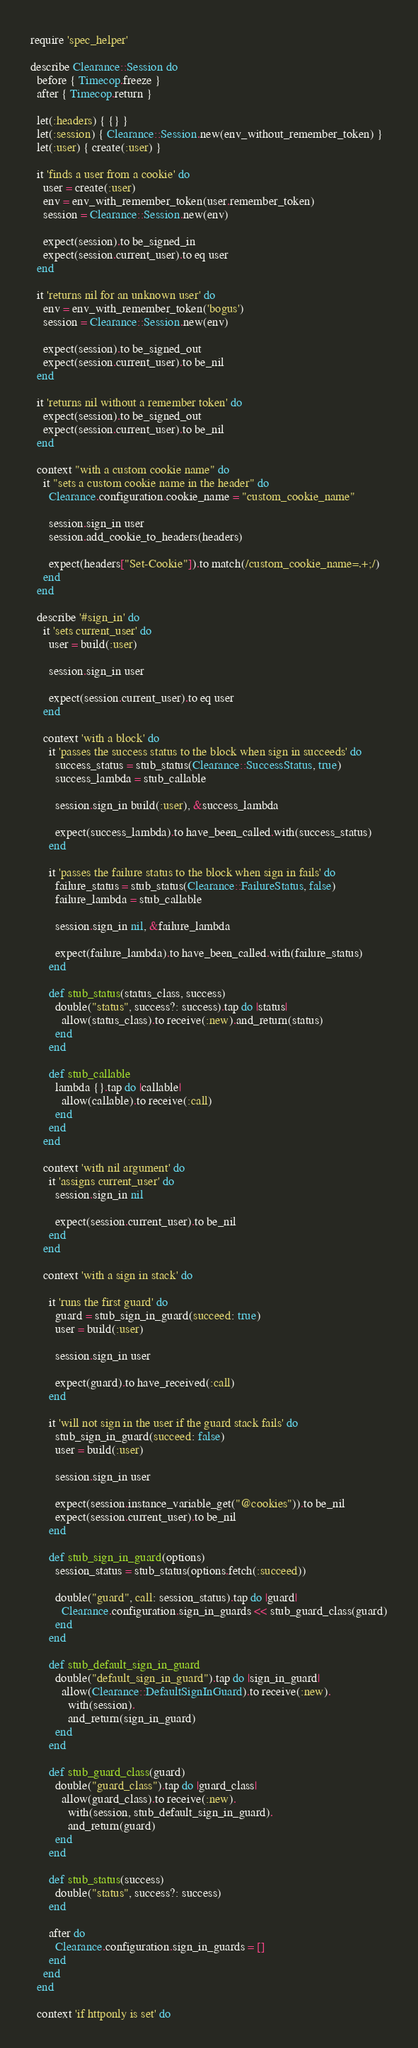Convert code to text. <code><loc_0><loc_0><loc_500><loc_500><_Ruby_>require 'spec_helper'

describe Clearance::Session do
  before { Timecop.freeze }
  after { Timecop.return }

  let(:headers) { {} }
  let(:session) { Clearance::Session.new(env_without_remember_token) }
  let(:user) { create(:user) }

  it 'finds a user from a cookie' do
    user = create(:user)
    env = env_with_remember_token(user.remember_token)
    session = Clearance::Session.new(env)

    expect(session).to be_signed_in
    expect(session.current_user).to eq user
  end

  it 'returns nil for an unknown user' do
    env = env_with_remember_token('bogus')
    session = Clearance::Session.new(env)

    expect(session).to be_signed_out
    expect(session.current_user).to be_nil
  end

  it 'returns nil without a remember token' do
    expect(session).to be_signed_out
    expect(session.current_user).to be_nil
  end

  context "with a custom cookie name" do
    it "sets a custom cookie name in the header" do
      Clearance.configuration.cookie_name = "custom_cookie_name"

      session.sign_in user
      session.add_cookie_to_headers(headers)

      expect(headers["Set-Cookie"]).to match(/custom_cookie_name=.+;/)
    end
  end

  describe '#sign_in' do
    it 'sets current_user' do
      user = build(:user)

      session.sign_in user

      expect(session.current_user).to eq user
    end

    context 'with a block' do
      it 'passes the success status to the block when sign in succeeds' do
        success_status = stub_status(Clearance::SuccessStatus, true)
        success_lambda = stub_callable

        session.sign_in build(:user), &success_lambda

        expect(success_lambda).to have_been_called.with(success_status)
      end

      it 'passes the failure status to the block when sign in fails' do
        failure_status = stub_status(Clearance::FailureStatus, false)
        failure_lambda = stub_callable

        session.sign_in nil, &failure_lambda

        expect(failure_lambda).to have_been_called.with(failure_status)
      end

      def stub_status(status_class, success)
        double("status", success?: success).tap do |status|
          allow(status_class).to receive(:new).and_return(status)
        end
      end

      def stub_callable
        lambda {}.tap do |callable|
          allow(callable).to receive(:call)
        end
      end
    end

    context 'with nil argument' do
      it 'assigns current_user' do
        session.sign_in nil

        expect(session.current_user).to be_nil
      end
    end

    context 'with a sign in stack' do

      it 'runs the first guard' do
        guard = stub_sign_in_guard(succeed: true)
        user = build(:user)

        session.sign_in user

        expect(guard).to have_received(:call)
      end

      it 'will not sign in the user if the guard stack fails' do
        stub_sign_in_guard(succeed: false)
        user = build(:user)

        session.sign_in user

        expect(session.instance_variable_get("@cookies")).to be_nil
        expect(session.current_user).to be_nil
      end

      def stub_sign_in_guard(options)
        session_status = stub_status(options.fetch(:succeed))

        double("guard", call: session_status).tap do |guard|
          Clearance.configuration.sign_in_guards << stub_guard_class(guard)
        end
      end

      def stub_default_sign_in_guard
        double("default_sign_in_guard").tap do |sign_in_guard|
          allow(Clearance::DefaultSignInGuard).to receive(:new).
            with(session).
            and_return(sign_in_guard)
        end
      end

      def stub_guard_class(guard)
        double("guard_class").tap do |guard_class|
          allow(guard_class).to receive(:new).
            with(session, stub_default_sign_in_guard).
            and_return(guard)
        end
      end

      def stub_status(success)
        double("status", success?: success)
      end

      after do
        Clearance.configuration.sign_in_guards = []
      end
    end
  end

  context 'if httponly is set' do</code> 